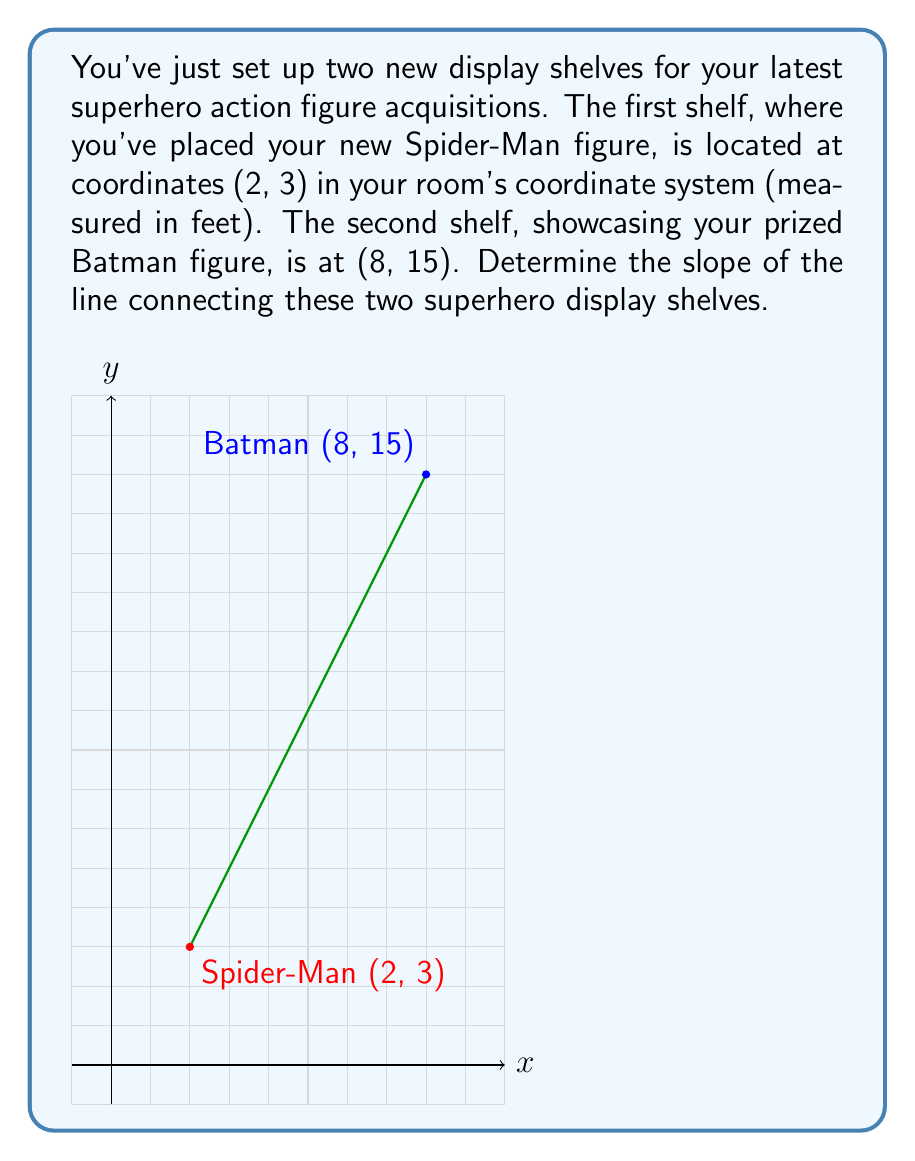Solve this math problem. To find the slope of the line connecting the two shelves, we'll use the slope formula:

$$m = \frac{y_2 - y_1}{x_2 - x_1}$$

Where $(x_1, y_1)$ is the first point and $(x_2, y_2)$ is the second point.

1) Identify the coordinates:
   Spider-Man shelf (first point): $(x_1, y_1) = (2, 3)$
   Batman shelf (second point): $(x_2, y_2) = (8, 15)$

2) Plug these values into the slope formula:

   $$m = \frac{15 - 3}{8 - 2}$$

3) Simplify the numerator and denominator:

   $$m = \frac{12}{6}$$

4) Reduce the fraction:

   $$m = 2$$

Thus, the slope of the line connecting your Spider-Man and Batman display shelves is 2.
Answer: $2$ 